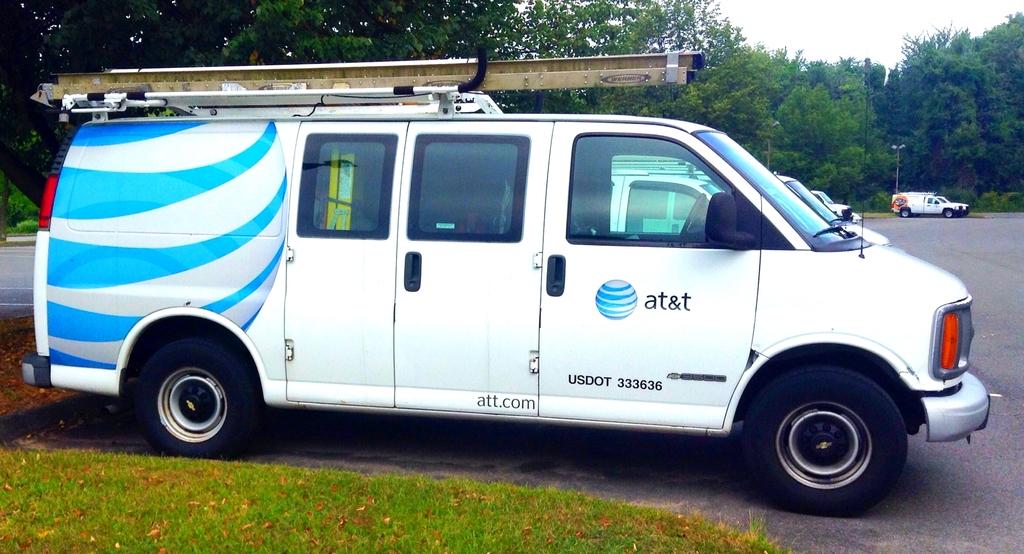What is the website on the door?
Make the answer very short. Att.com. What company owns this can?
Provide a short and direct response. At&t. 